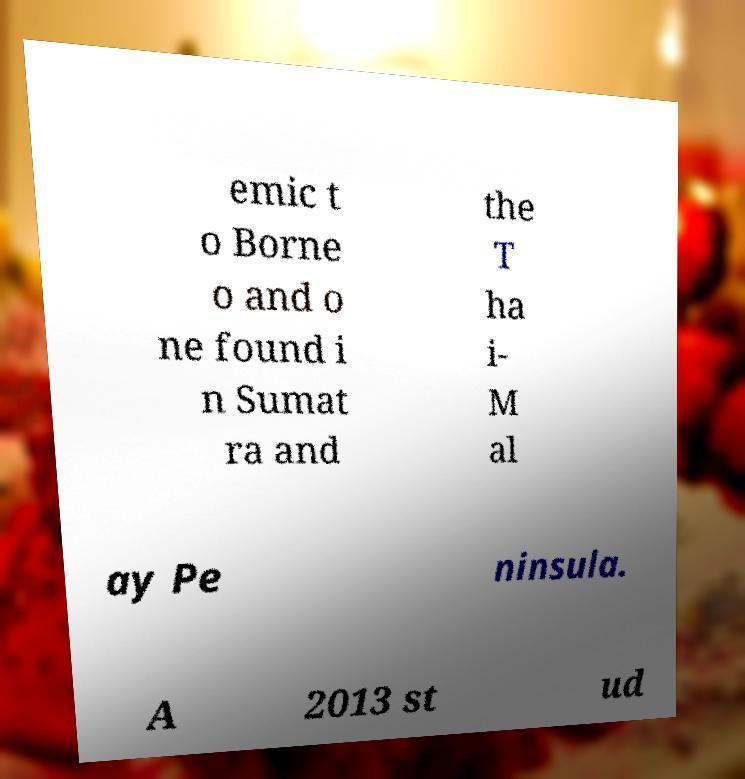Could you extract and type out the text from this image? emic t o Borne o and o ne found i n Sumat ra and the T ha i- M al ay Pe ninsula. A 2013 st ud 